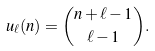<formula> <loc_0><loc_0><loc_500><loc_500>u _ { \ell } ( n ) = \binom { n + \ell - 1 } { \ell - 1 } .</formula> 